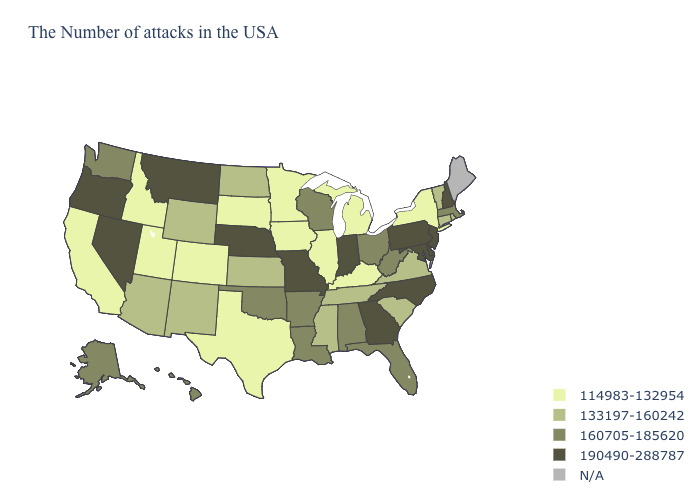What is the lowest value in states that border Virginia?
Write a very short answer. 114983-132954. What is the lowest value in the USA?
Answer briefly. 114983-132954. Name the states that have a value in the range 160705-185620?
Concise answer only. Massachusetts, West Virginia, Ohio, Florida, Alabama, Wisconsin, Louisiana, Arkansas, Oklahoma, Washington, Alaska, Hawaii. What is the value of New Hampshire?
Write a very short answer. 190490-288787. What is the value of North Carolina?
Be succinct. 190490-288787. Does Montana have the highest value in the West?
Quick response, please. Yes. Does Michigan have the highest value in the MidWest?
Quick response, please. No. Which states have the lowest value in the West?
Write a very short answer. Colorado, Utah, Idaho, California. Name the states that have a value in the range N/A?
Answer briefly. Maine. Does Iowa have the lowest value in the USA?
Give a very brief answer. Yes. Is the legend a continuous bar?
Be succinct. No. 